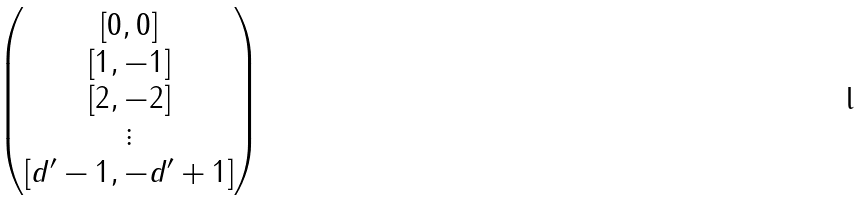Convert formula to latex. <formula><loc_0><loc_0><loc_500><loc_500>\begin{pmatrix} [ 0 , 0 ] \\ [ 1 , - 1 ] \\ [ 2 , - 2 ] \\ \vdots \\ [ d ^ { \prime } - 1 , - d ^ { \prime } + 1 ] \end{pmatrix}</formula> 